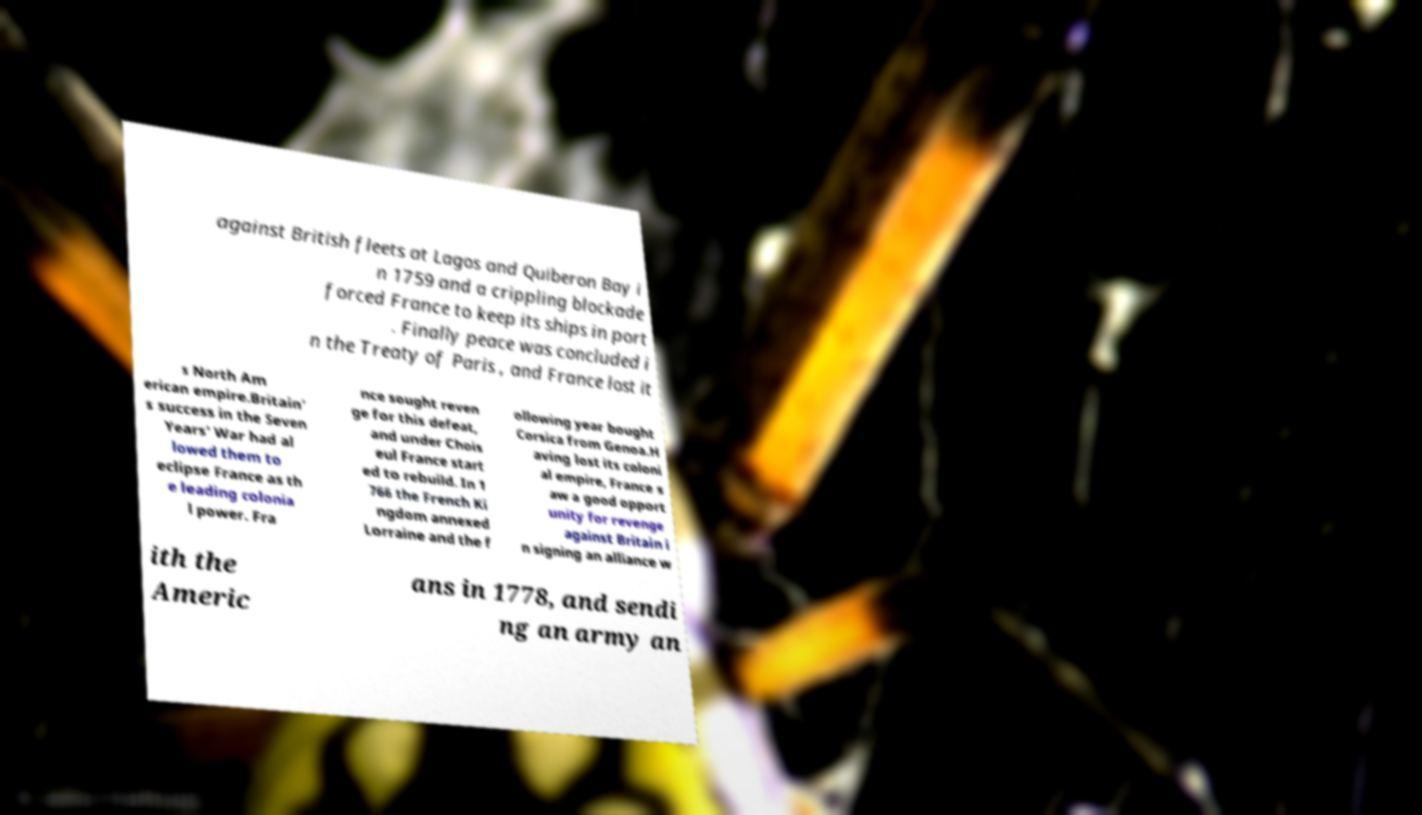Please read and relay the text visible in this image. What does it say? against British fleets at Lagos and Quiberon Bay i n 1759 and a crippling blockade forced France to keep its ships in port . Finally peace was concluded i n the Treaty of Paris , and France lost it s North Am erican empire.Britain' s success in the Seven Years' War had al lowed them to eclipse France as th e leading colonia l power. Fra nce sought reven ge for this defeat, and under Chois eul France start ed to rebuild. In 1 766 the French Ki ngdom annexed Lorraine and the f ollowing year bought Corsica from Genoa.H aving lost its coloni al empire, France s aw a good opport unity for revenge against Britain i n signing an alliance w ith the Americ ans in 1778, and sendi ng an army an 